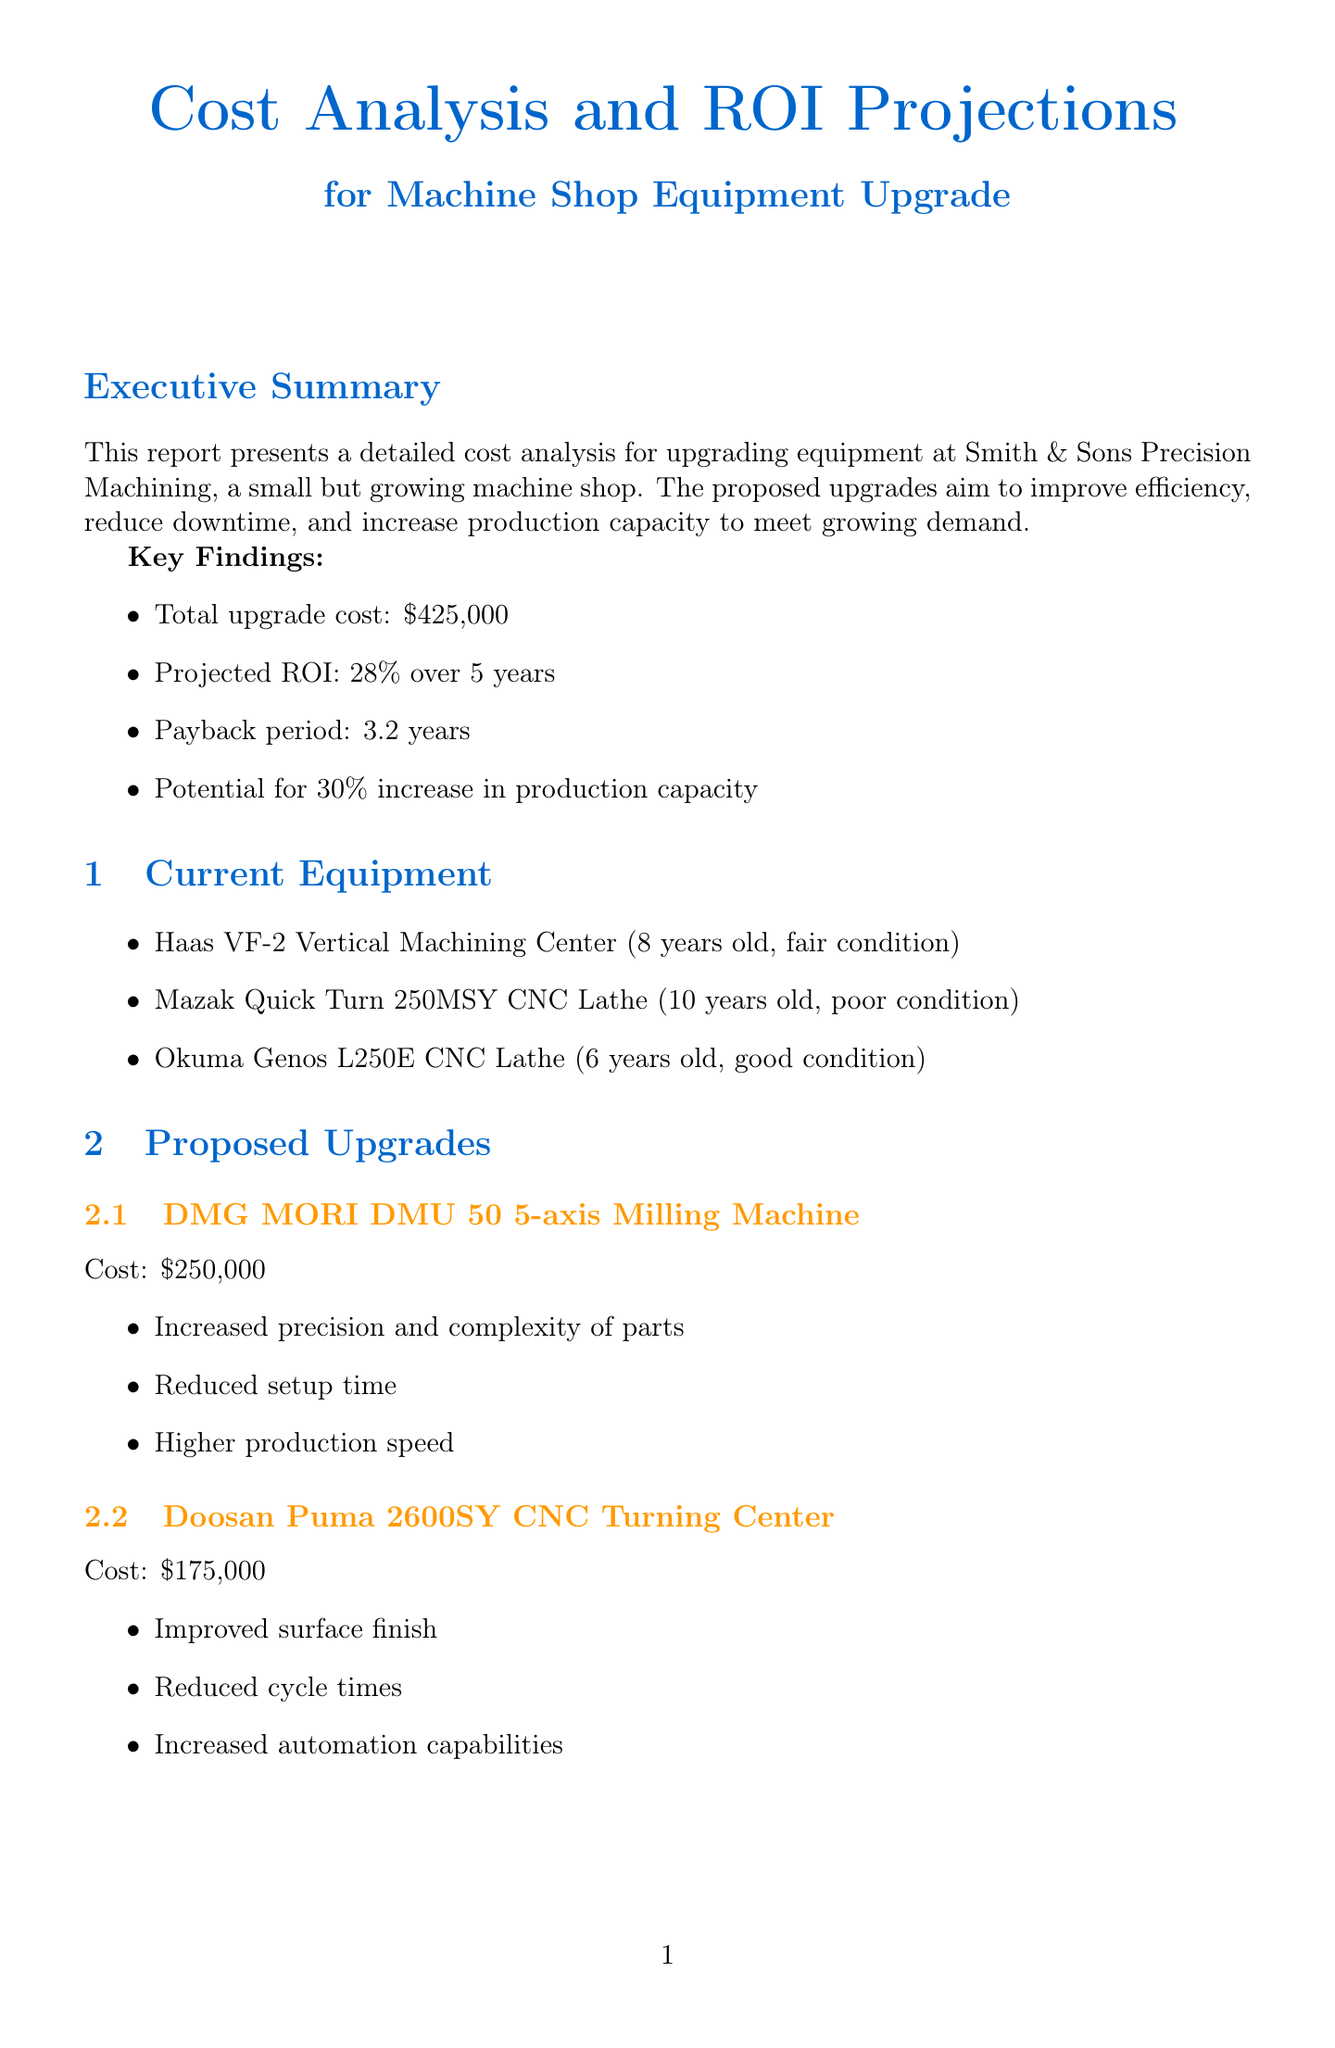What is the total upgrade cost? The total upgrade cost is listed as $425,000 in the document.
Answer: $425,000 What is the projected ROI over 5 years? The projected ROI is specified in the key findings section of the report as 28% over 5 years.
Answer: 28% What is the payback period for the investment? The payback period is mentioned as 3.2 years in the key findings section of the report.
Answer: 3.2 years Which financing option has the lowest monthly payment? By comparing the monthly payments of the financing options, the SBA 7(a) Loan has the lowest payment of $5,450.
Answer: $5,450 How much is allocated for training costs in the cost breakdown? The training costs in the cost breakdown section of the document state it is $10,000.
Answer: $10,000 What are the expected yearly energy savings? The yearly energy savings are indicated in the ROI projections as $8,000.
Answer: $8,000 What is the duration for equipment order and delivery? The implementation timeline specifies that the duration for equipment order and delivery is 8-12 weeks.
Answer: 8-12 weeks What kind of risk does the document highlight related to production? The document highlights the risk of initial production slowdown in the risk analysis section.
Answer: Initial production slowdown What recommendation is made regarding financing? One recommendation made in the conclusion is to opt for the SBA 7(a) loan for more favorable long-term financing.
Answer: SBA 7(a) loan 